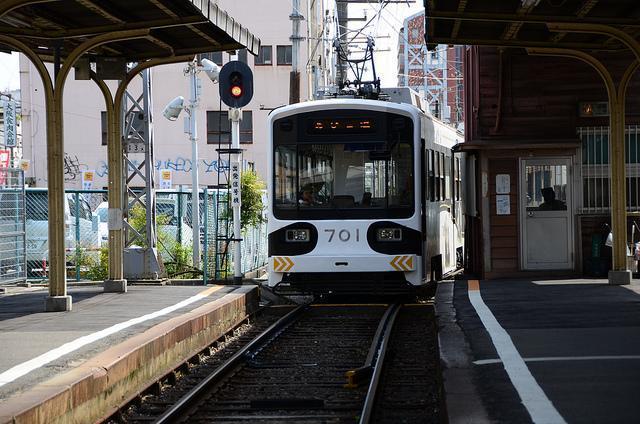How many cars are in the picture?
Give a very brief answer. 2. How many cats are there?
Give a very brief answer. 0. 